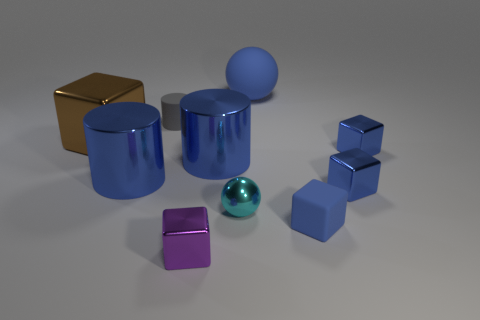Are there any other brown objects of the same shape as the brown object?
Ensure brevity in your answer.  No. There is another rubber thing that is the same size as the brown object; what shape is it?
Ensure brevity in your answer.  Sphere. How many blue things are behind the small cyan metallic sphere and in front of the blue sphere?
Offer a terse response. 4. Are there fewer gray cylinders to the right of the blue ball than red metallic cylinders?
Offer a terse response. No. Is there a red shiny block of the same size as the blue rubber cube?
Offer a terse response. No. What color is the sphere that is made of the same material as the brown thing?
Offer a terse response. Cyan. There is a small rubber object that is to the left of the blue sphere; how many brown metal things are to the right of it?
Make the answer very short. 0. There is a tiny object that is on the left side of the cyan shiny thing and in front of the tiny gray rubber object; what material is it made of?
Provide a short and direct response. Metal. There is a blue shiny thing on the left side of the gray rubber cylinder; does it have the same shape as the gray thing?
Offer a terse response. Yes. Are there fewer large green matte spheres than small rubber cylinders?
Offer a terse response. Yes. 